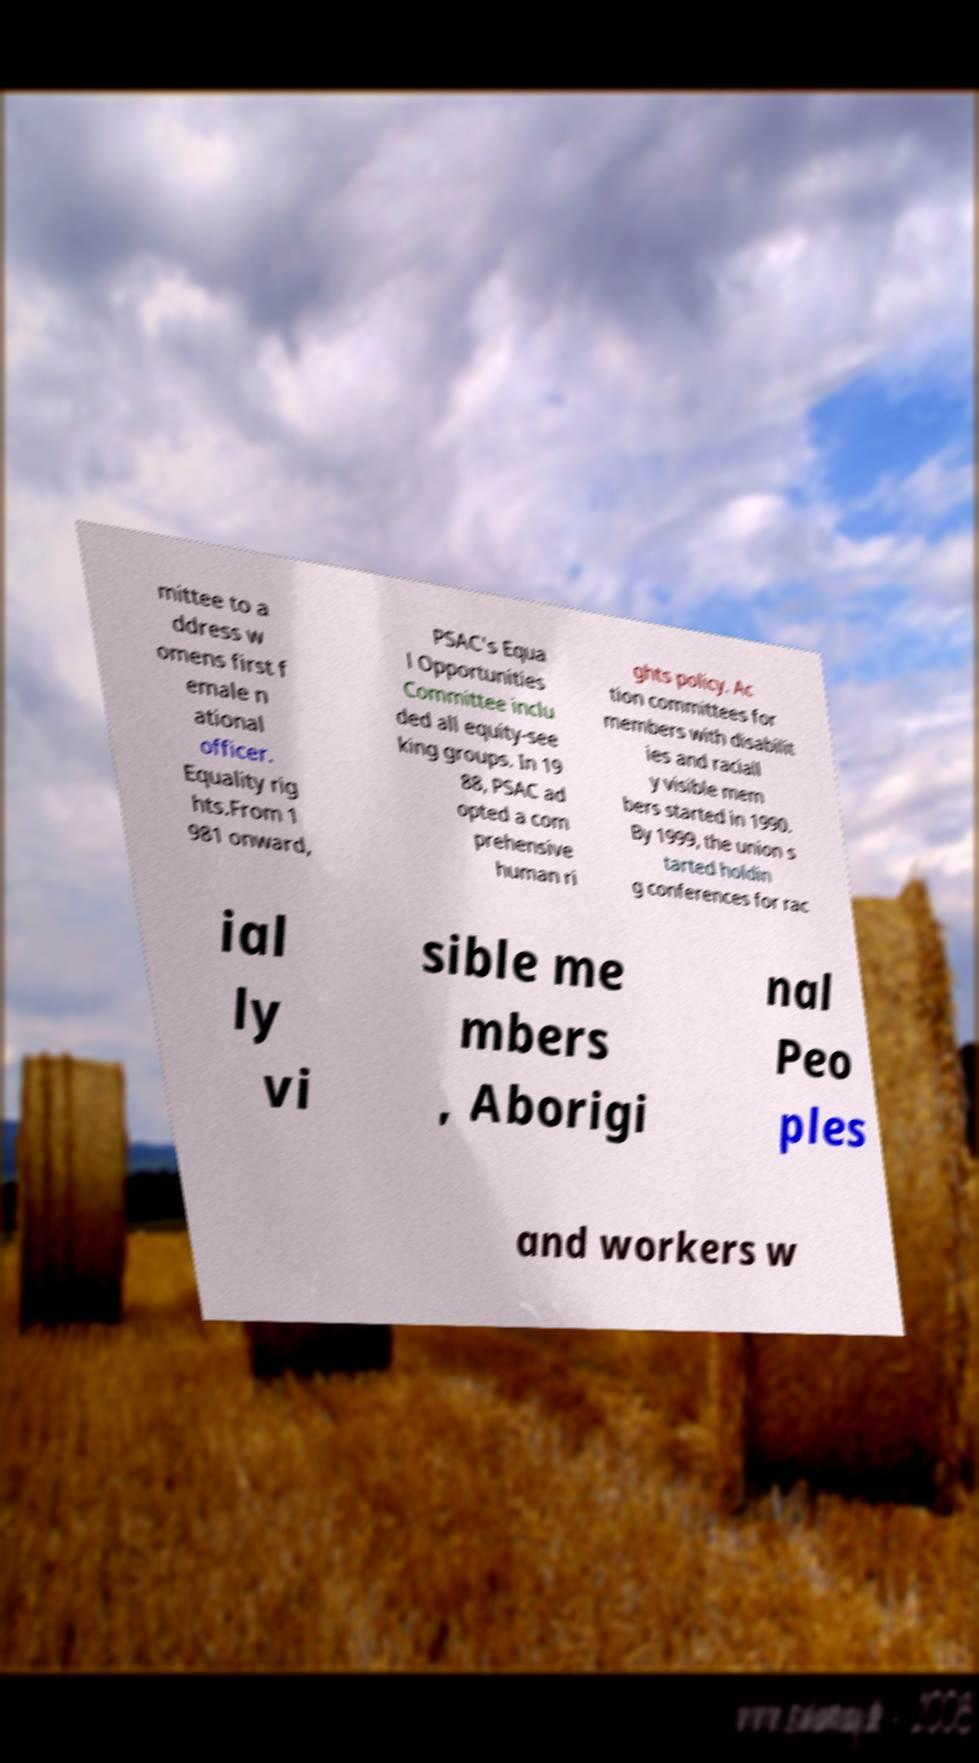Can you accurately transcribe the text from the provided image for me? mittee to a ddress w omens first f emale n ational officer. Equality rig hts.From 1 981 onward, PSAC's Equa l Opportunities Committee inclu ded all equity-see king groups. In 19 88, PSAC ad opted a com prehensive human ri ghts policy. Ac tion committees for members with disabilit ies and raciall y visible mem bers started in 1990. By 1999, the union s tarted holdin g conferences for rac ial ly vi sible me mbers , Aborigi nal Peo ples and workers w 